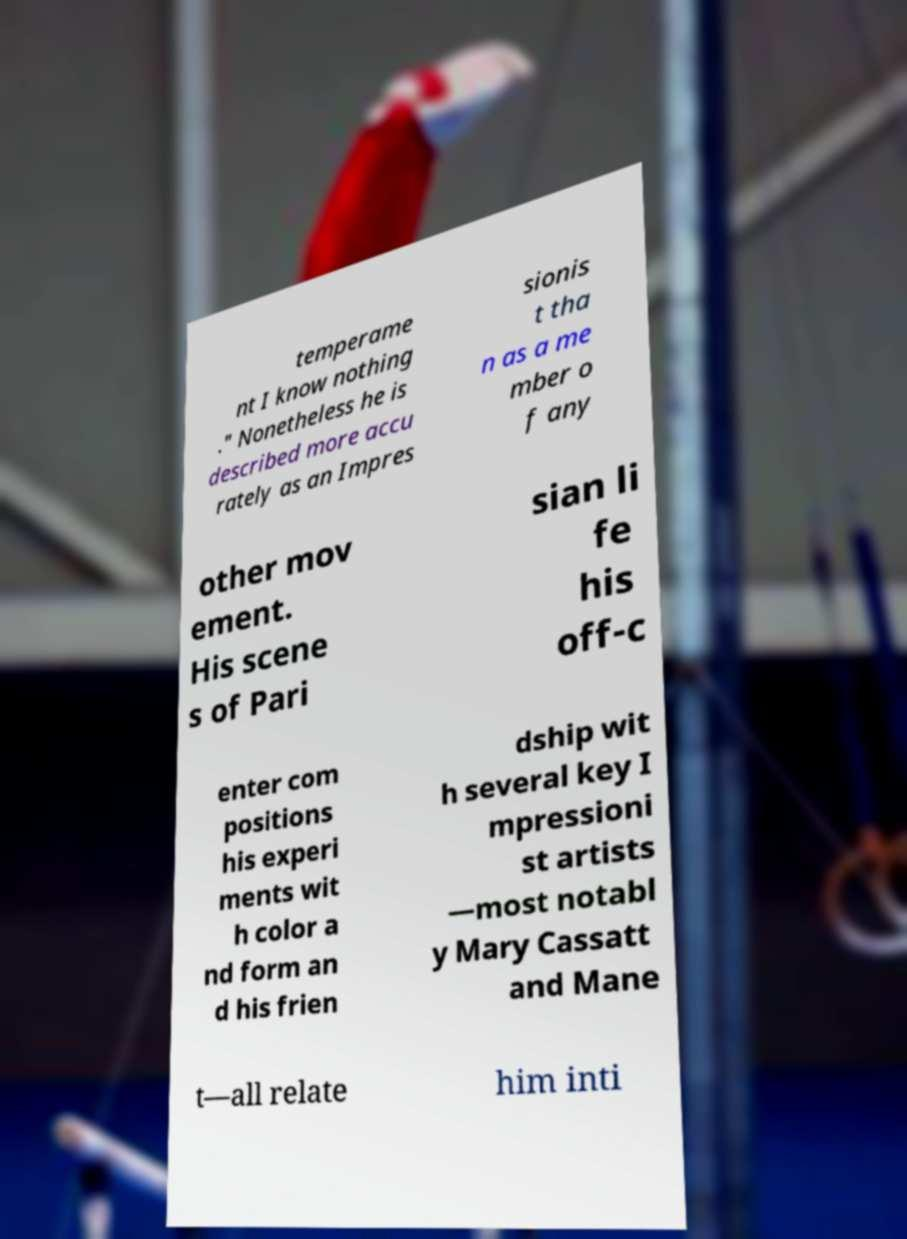Please read and relay the text visible in this image. What does it say? temperame nt I know nothing ." Nonetheless he is described more accu rately as an Impres sionis t tha n as a me mber o f any other mov ement. His scene s of Pari sian li fe his off-c enter com positions his experi ments wit h color a nd form an d his frien dship wit h several key I mpressioni st artists —most notabl y Mary Cassatt and Mane t—all relate him inti 